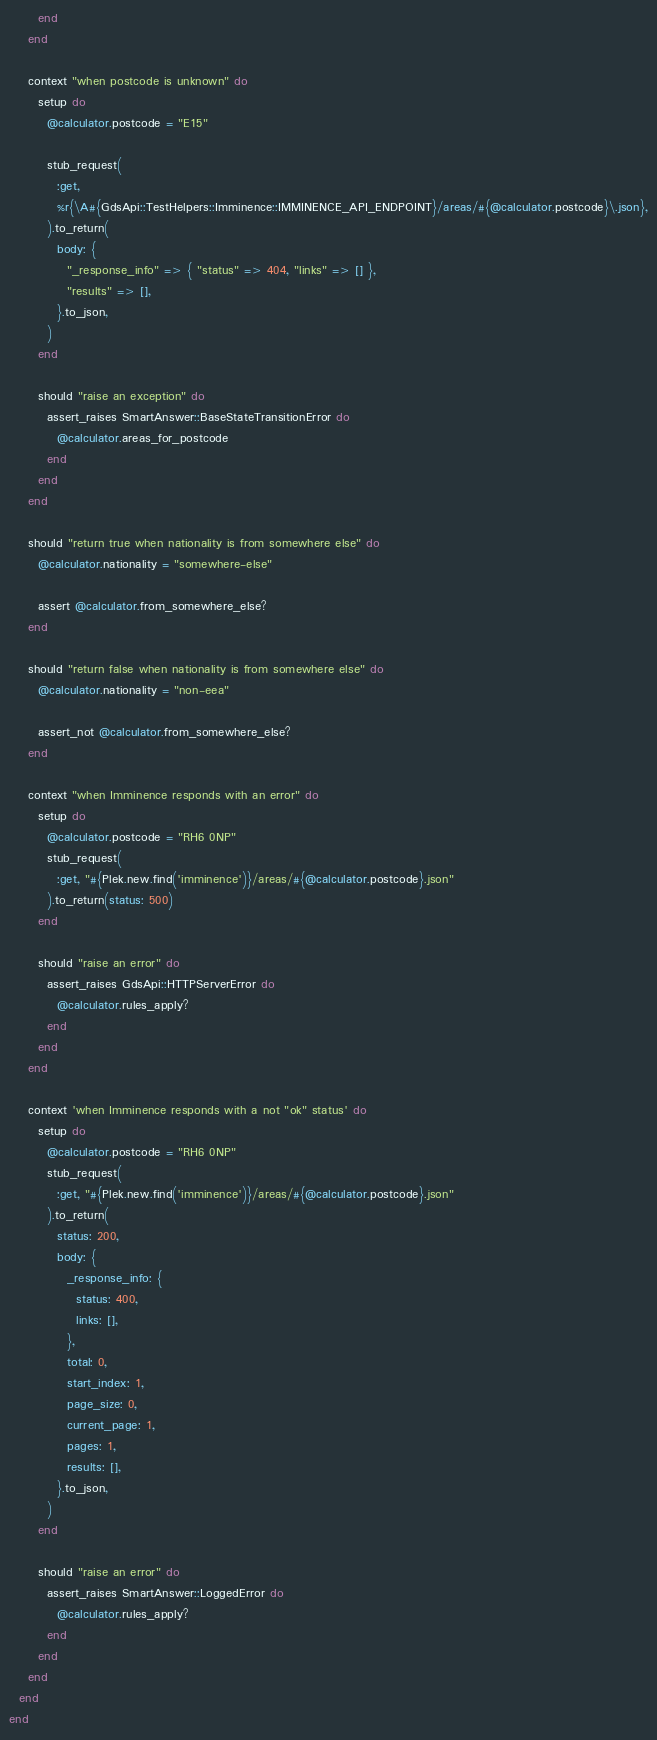<code> <loc_0><loc_0><loc_500><loc_500><_Ruby_>      end
    end

    context "when postcode is unknown" do
      setup do
        @calculator.postcode = "E15"

        stub_request(
          :get,
          %r{\A#{GdsApi::TestHelpers::Imminence::IMMINENCE_API_ENDPOINT}/areas/#{@calculator.postcode}\.json},
        ).to_return(
          body: {
            "_response_info" => { "status" => 404, "links" => [] },
            "results" => [],
          }.to_json,
        )
      end

      should "raise an exception" do
        assert_raises SmartAnswer::BaseStateTransitionError do
          @calculator.areas_for_postcode
        end
      end
    end

    should "return true when nationality is from somewhere else" do
      @calculator.nationality = "somewhere-else"

      assert @calculator.from_somewhere_else?
    end

    should "return false when nationality is from somewhere else" do
      @calculator.nationality = "non-eea"

      assert_not @calculator.from_somewhere_else?
    end

    context "when Imminence responds with an error" do
      setup do
        @calculator.postcode = "RH6 0NP"
        stub_request(
          :get, "#{Plek.new.find('imminence')}/areas/#{@calculator.postcode}.json"
        ).to_return(status: 500)
      end

      should "raise an error" do
        assert_raises GdsApi::HTTPServerError do
          @calculator.rules_apply?
        end
      end
    end

    context 'when Imminence responds with a not "ok" status' do
      setup do
        @calculator.postcode = "RH6 0NP"
        stub_request(
          :get, "#{Plek.new.find('imminence')}/areas/#{@calculator.postcode}.json"
        ).to_return(
          status: 200,
          body: {
            _response_info: {
              status: 400,
              links: [],
            },
            total: 0,
            start_index: 1,
            page_size: 0,
            current_page: 1,
            pages: 1,
            results: [],
          }.to_json,
        )
      end

      should "raise an error" do
        assert_raises SmartAnswer::LoggedError do
          @calculator.rules_apply?
        end
      end
    end
  end
end
</code> 